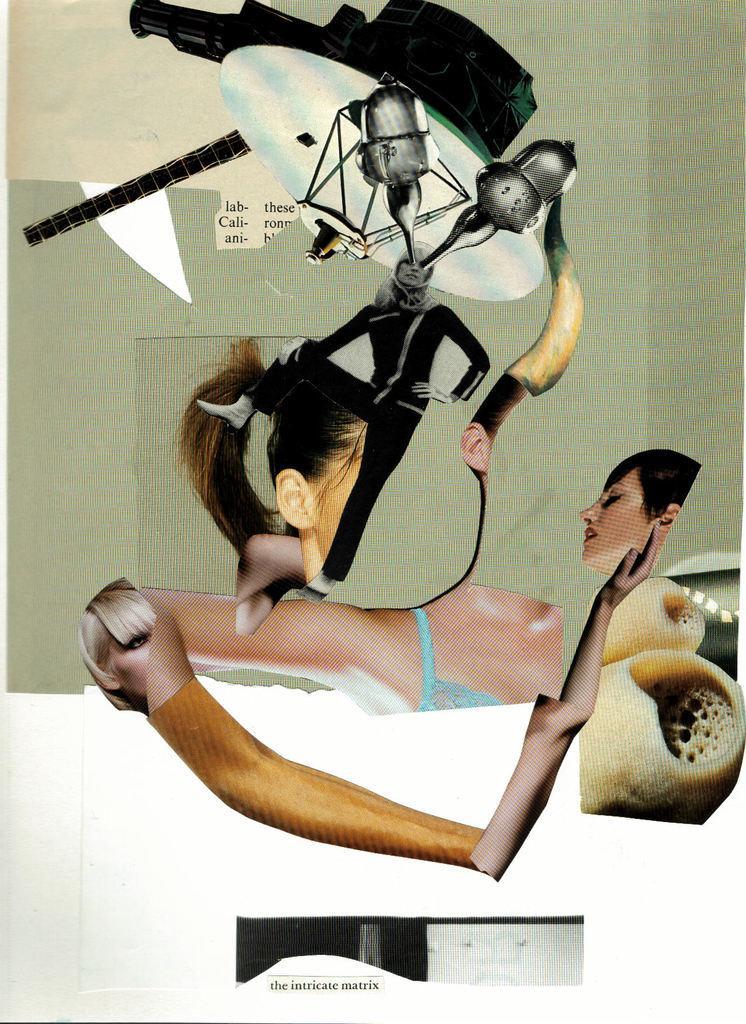Can you describe this image briefly? This is an edited image. In this image I can see the person's face, hand, hair and I can see one person's standing and wearing the black color dress. I can also see few other objects in the top. 